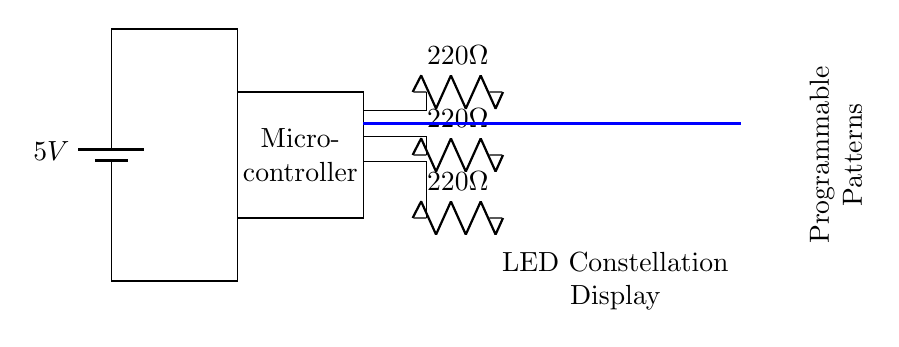What is the voltage of this circuit? The voltage is 5V, as indicated by the battery symbol at the top left of the circuit. It signifies a power supply providing 5 volts to the circuit.
Answer: 5 volts What type of microcontroller is used in this circuit? The specific type of microcontroller is not indicated in the diagram, only labeled as "Microcontroller." This suggests a generic microcontroller is intended for controlling the LED patterns.
Answer: Microcontroller How many LEDs are present in the display? The display consists of a 3x3 LED matrix, which totals to nine individual LEDs. This is seen by counting the rows and columns of the LED nodes in the diagram.
Answer: Nine What is the purpose of the resistors connected to the LEDs? The resistors, labeled as 220 ohms, serve to limit the current flowing through each LED, protecting them from excess current that could cause damage. The resistors ensure that the LEDs operate within safe current levels.
Answer: Limit current How are the LEDs powered in this circuit? The LEDs are powered by connecting them to the battery through the resistors and the microcontroller, allowing the microcontroller to control the LED states and patterns by enabling or disabling current flow through the LEDs.
Answer: Through the microcontroller What does the blue line in the circuit represent? The blue lines represent data connections, indicating how signals are sent from the microcontroller to the LEDs. They show the pathway for the microcontroller to communicate with the LED matrix for controlling the patterns.
Answer: Data connections 